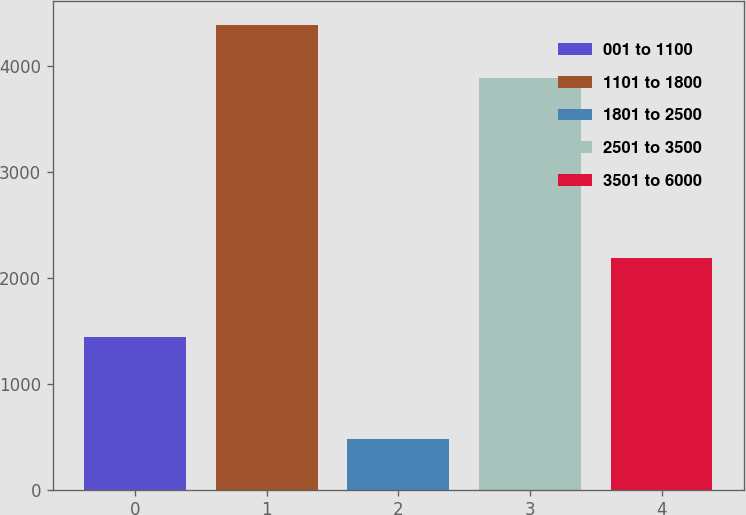Convert chart. <chart><loc_0><loc_0><loc_500><loc_500><bar_chart><fcel>001 to 1100<fcel>1101 to 1800<fcel>1801 to 2500<fcel>2501 to 3500<fcel>3501 to 6000<nl><fcel>1444<fcel>4395<fcel>480<fcel>3893<fcel>2190<nl></chart> 